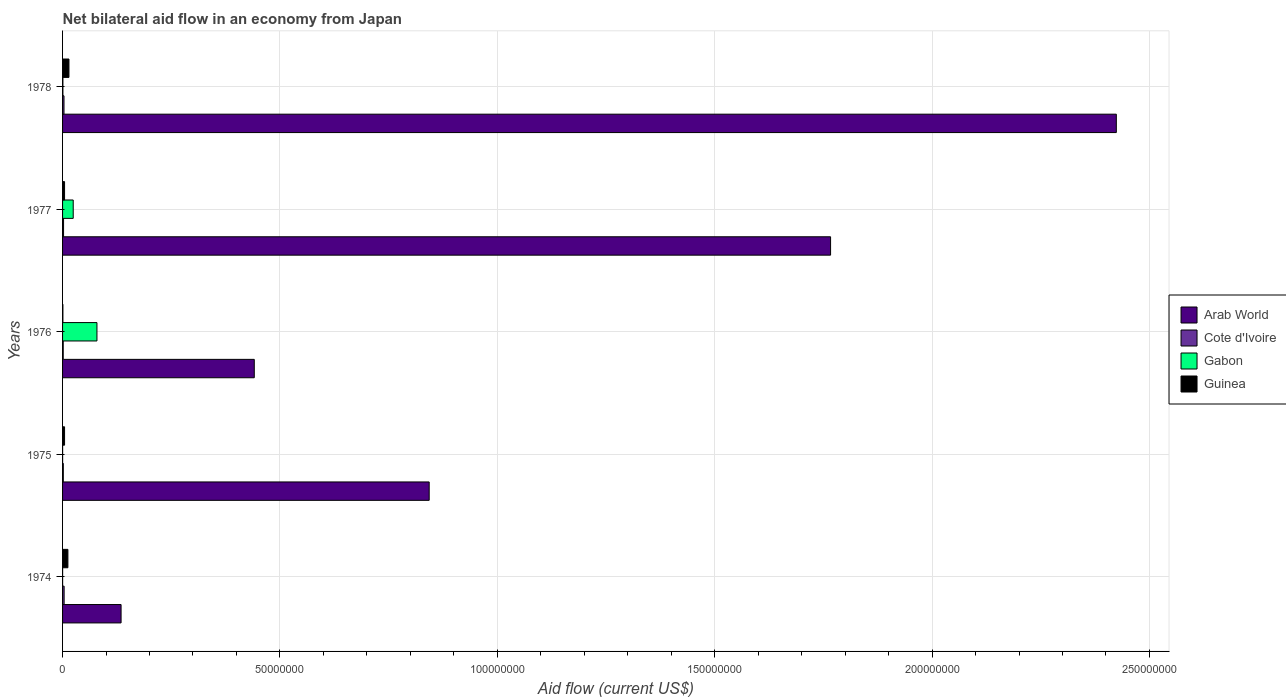Are the number of bars per tick equal to the number of legend labels?
Provide a succinct answer. Yes. Are the number of bars on each tick of the Y-axis equal?
Make the answer very short. Yes. How many bars are there on the 3rd tick from the bottom?
Make the answer very short. 4. What is the label of the 5th group of bars from the top?
Keep it short and to the point. 1974. Across all years, what is the maximum net bilateral aid flow in Gabon?
Your answer should be very brief. 7.91e+06. In which year was the net bilateral aid flow in Guinea maximum?
Keep it short and to the point. 1978. In which year was the net bilateral aid flow in Cote d'Ivoire minimum?
Keep it short and to the point. 1976. What is the total net bilateral aid flow in Arab World in the graph?
Your answer should be very brief. 5.61e+08. What is the difference between the net bilateral aid flow in Guinea in 1978 and the net bilateral aid flow in Cote d'Ivoire in 1977?
Make the answer very short. 1.24e+06. What is the average net bilateral aid flow in Arab World per year?
Your response must be concise. 1.12e+08. In the year 1978, what is the difference between the net bilateral aid flow in Arab World and net bilateral aid flow in Cote d'Ivoire?
Offer a very short reply. 2.42e+08. What is the ratio of the net bilateral aid flow in Cote d'Ivoire in 1974 to that in 1978?
Ensure brevity in your answer.  1.09. What is the difference between the highest and the second highest net bilateral aid flow in Arab World?
Your answer should be very brief. 6.57e+07. What is the difference between the highest and the lowest net bilateral aid flow in Gabon?
Your answer should be very brief. 7.90e+06. Is the sum of the net bilateral aid flow in Gabon in 1975 and 1977 greater than the maximum net bilateral aid flow in Cote d'Ivoire across all years?
Offer a terse response. Yes. What does the 2nd bar from the top in 1977 represents?
Your answer should be compact. Gabon. What does the 4th bar from the bottom in 1974 represents?
Keep it short and to the point. Guinea. Is it the case that in every year, the sum of the net bilateral aid flow in Arab World and net bilateral aid flow in Cote d'Ivoire is greater than the net bilateral aid flow in Gabon?
Provide a short and direct response. Yes. How many bars are there?
Ensure brevity in your answer.  20. Are the values on the major ticks of X-axis written in scientific E-notation?
Give a very brief answer. No. How are the legend labels stacked?
Your answer should be compact. Vertical. What is the title of the graph?
Offer a terse response. Net bilateral aid flow in an economy from Japan. What is the label or title of the X-axis?
Offer a terse response. Aid flow (current US$). What is the label or title of the Y-axis?
Keep it short and to the point. Years. What is the Aid flow (current US$) of Arab World in 1974?
Offer a very short reply. 1.35e+07. What is the Aid flow (current US$) in Guinea in 1974?
Provide a succinct answer. 1.23e+06. What is the Aid flow (current US$) of Arab World in 1975?
Your answer should be compact. 8.43e+07. What is the Aid flow (current US$) of Cote d'Ivoire in 1975?
Provide a short and direct response. 1.70e+05. What is the Aid flow (current US$) of Gabon in 1975?
Your answer should be very brief. 10000. What is the Aid flow (current US$) of Guinea in 1975?
Make the answer very short. 4.60e+05. What is the Aid flow (current US$) of Arab World in 1976?
Offer a very short reply. 4.41e+07. What is the Aid flow (current US$) of Gabon in 1976?
Your answer should be very brief. 7.91e+06. What is the Aid flow (current US$) of Guinea in 1976?
Ensure brevity in your answer.  8.00e+04. What is the Aid flow (current US$) of Arab World in 1977?
Ensure brevity in your answer.  1.77e+08. What is the Aid flow (current US$) in Gabon in 1977?
Keep it short and to the point. 2.45e+06. What is the Aid flow (current US$) in Arab World in 1978?
Your response must be concise. 2.42e+08. What is the Aid flow (current US$) in Cote d'Ivoire in 1978?
Offer a terse response. 3.30e+05. What is the Aid flow (current US$) of Gabon in 1978?
Give a very brief answer. 8.00e+04. What is the Aid flow (current US$) in Guinea in 1978?
Ensure brevity in your answer.  1.47e+06. Across all years, what is the maximum Aid flow (current US$) of Arab World?
Offer a terse response. 2.42e+08. Across all years, what is the maximum Aid flow (current US$) of Gabon?
Provide a succinct answer. 7.91e+06. Across all years, what is the maximum Aid flow (current US$) in Guinea?
Ensure brevity in your answer.  1.47e+06. Across all years, what is the minimum Aid flow (current US$) in Arab World?
Give a very brief answer. 1.35e+07. What is the total Aid flow (current US$) of Arab World in the graph?
Offer a very short reply. 5.61e+08. What is the total Aid flow (current US$) of Cote d'Ivoire in the graph?
Your answer should be compact. 1.24e+06. What is the total Aid flow (current US$) in Gabon in the graph?
Provide a succinct answer. 1.05e+07. What is the total Aid flow (current US$) in Guinea in the graph?
Provide a succinct answer. 3.70e+06. What is the difference between the Aid flow (current US$) in Arab World in 1974 and that in 1975?
Ensure brevity in your answer.  -7.09e+07. What is the difference between the Aid flow (current US$) of Cote d'Ivoire in 1974 and that in 1975?
Provide a succinct answer. 1.90e+05. What is the difference between the Aid flow (current US$) of Guinea in 1974 and that in 1975?
Your answer should be compact. 7.70e+05. What is the difference between the Aid flow (current US$) of Arab World in 1974 and that in 1976?
Your answer should be compact. -3.06e+07. What is the difference between the Aid flow (current US$) in Gabon in 1974 and that in 1976?
Provide a succinct answer. -7.90e+06. What is the difference between the Aid flow (current US$) of Guinea in 1974 and that in 1976?
Offer a very short reply. 1.15e+06. What is the difference between the Aid flow (current US$) in Arab World in 1974 and that in 1977?
Offer a terse response. -1.63e+08. What is the difference between the Aid flow (current US$) in Gabon in 1974 and that in 1977?
Give a very brief answer. -2.44e+06. What is the difference between the Aid flow (current US$) in Guinea in 1974 and that in 1977?
Offer a very short reply. 7.70e+05. What is the difference between the Aid flow (current US$) of Arab World in 1974 and that in 1978?
Offer a terse response. -2.29e+08. What is the difference between the Aid flow (current US$) in Gabon in 1974 and that in 1978?
Offer a very short reply. -7.00e+04. What is the difference between the Aid flow (current US$) in Arab World in 1975 and that in 1976?
Give a very brief answer. 4.02e+07. What is the difference between the Aid flow (current US$) of Cote d'Ivoire in 1975 and that in 1976?
Make the answer very short. 2.00e+04. What is the difference between the Aid flow (current US$) of Gabon in 1975 and that in 1976?
Ensure brevity in your answer.  -7.90e+06. What is the difference between the Aid flow (current US$) of Guinea in 1975 and that in 1976?
Your answer should be very brief. 3.80e+05. What is the difference between the Aid flow (current US$) of Arab World in 1975 and that in 1977?
Keep it short and to the point. -9.23e+07. What is the difference between the Aid flow (current US$) of Gabon in 1975 and that in 1977?
Make the answer very short. -2.44e+06. What is the difference between the Aid flow (current US$) in Arab World in 1975 and that in 1978?
Provide a succinct answer. -1.58e+08. What is the difference between the Aid flow (current US$) of Cote d'Ivoire in 1975 and that in 1978?
Offer a very short reply. -1.60e+05. What is the difference between the Aid flow (current US$) of Gabon in 1975 and that in 1978?
Your response must be concise. -7.00e+04. What is the difference between the Aid flow (current US$) of Guinea in 1975 and that in 1978?
Make the answer very short. -1.01e+06. What is the difference between the Aid flow (current US$) of Arab World in 1976 and that in 1977?
Give a very brief answer. -1.33e+08. What is the difference between the Aid flow (current US$) of Gabon in 1976 and that in 1977?
Your response must be concise. 5.46e+06. What is the difference between the Aid flow (current US$) of Guinea in 1976 and that in 1977?
Your answer should be very brief. -3.80e+05. What is the difference between the Aid flow (current US$) of Arab World in 1976 and that in 1978?
Ensure brevity in your answer.  -1.98e+08. What is the difference between the Aid flow (current US$) of Cote d'Ivoire in 1976 and that in 1978?
Offer a very short reply. -1.80e+05. What is the difference between the Aid flow (current US$) of Gabon in 1976 and that in 1978?
Ensure brevity in your answer.  7.83e+06. What is the difference between the Aid flow (current US$) of Guinea in 1976 and that in 1978?
Provide a short and direct response. -1.39e+06. What is the difference between the Aid flow (current US$) in Arab World in 1977 and that in 1978?
Your answer should be very brief. -6.57e+07. What is the difference between the Aid flow (current US$) in Cote d'Ivoire in 1977 and that in 1978?
Offer a very short reply. -1.00e+05. What is the difference between the Aid flow (current US$) in Gabon in 1977 and that in 1978?
Your answer should be compact. 2.37e+06. What is the difference between the Aid flow (current US$) in Guinea in 1977 and that in 1978?
Ensure brevity in your answer.  -1.01e+06. What is the difference between the Aid flow (current US$) of Arab World in 1974 and the Aid flow (current US$) of Cote d'Ivoire in 1975?
Provide a succinct answer. 1.33e+07. What is the difference between the Aid flow (current US$) of Arab World in 1974 and the Aid flow (current US$) of Gabon in 1975?
Give a very brief answer. 1.34e+07. What is the difference between the Aid flow (current US$) of Arab World in 1974 and the Aid flow (current US$) of Guinea in 1975?
Make the answer very short. 1.30e+07. What is the difference between the Aid flow (current US$) in Cote d'Ivoire in 1974 and the Aid flow (current US$) in Gabon in 1975?
Provide a succinct answer. 3.50e+05. What is the difference between the Aid flow (current US$) in Cote d'Ivoire in 1974 and the Aid flow (current US$) in Guinea in 1975?
Offer a very short reply. -1.00e+05. What is the difference between the Aid flow (current US$) in Gabon in 1974 and the Aid flow (current US$) in Guinea in 1975?
Your answer should be very brief. -4.50e+05. What is the difference between the Aid flow (current US$) in Arab World in 1974 and the Aid flow (current US$) in Cote d'Ivoire in 1976?
Make the answer very short. 1.33e+07. What is the difference between the Aid flow (current US$) in Arab World in 1974 and the Aid flow (current US$) in Gabon in 1976?
Your answer should be very brief. 5.55e+06. What is the difference between the Aid flow (current US$) in Arab World in 1974 and the Aid flow (current US$) in Guinea in 1976?
Your answer should be compact. 1.34e+07. What is the difference between the Aid flow (current US$) of Cote d'Ivoire in 1974 and the Aid flow (current US$) of Gabon in 1976?
Provide a short and direct response. -7.55e+06. What is the difference between the Aid flow (current US$) of Gabon in 1974 and the Aid flow (current US$) of Guinea in 1976?
Provide a short and direct response. -7.00e+04. What is the difference between the Aid flow (current US$) of Arab World in 1974 and the Aid flow (current US$) of Cote d'Ivoire in 1977?
Your answer should be compact. 1.32e+07. What is the difference between the Aid flow (current US$) in Arab World in 1974 and the Aid flow (current US$) in Gabon in 1977?
Your response must be concise. 1.10e+07. What is the difference between the Aid flow (current US$) in Arab World in 1974 and the Aid flow (current US$) in Guinea in 1977?
Your answer should be compact. 1.30e+07. What is the difference between the Aid flow (current US$) in Cote d'Ivoire in 1974 and the Aid flow (current US$) in Gabon in 1977?
Offer a terse response. -2.09e+06. What is the difference between the Aid flow (current US$) in Gabon in 1974 and the Aid flow (current US$) in Guinea in 1977?
Make the answer very short. -4.50e+05. What is the difference between the Aid flow (current US$) of Arab World in 1974 and the Aid flow (current US$) of Cote d'Ivoire in 1978?
Keep it short and to the point. 1.31e+07. What is the difference between the Aid flow (current US$) of Arab World in 1974 and the Aid flow (current US$) of Gabon in 1978?
Offer a very short reply. 1.34e+07. What is the difference between the Aid flow (current US$) of Arab World in 1974 and the Aid flow (current US$) of Guinea in 1978?
Keep it short and to the point. 1.20e+07. What is the difference between the Aid flow (current US$) in Cote d'Ivoire in 1974 and the Aid flow (current US$) in Gabon in 1978?
Offer a very short reply. 2.80e+05. What is the difference between the Aid flow (current US$) in Cote d'Ivoire in 1974 and the Aid flow (current US$) in Guinea in 1978?
Make the answer very short. -1.11e+06. What is the difference between the Aid flow (current US$) in Gabon in 1974 and the Aid flow (current US$) in Guinea in 1978?
Ensure brevity in your answer.  -1.46e+06. What is the difference between the Aid flow (current US$) of Arab World in 1975 and the Aid flow (current US$) of Cote d'Ivoire in 1976?
Your answer should be compact. 8.42e+07. What is the difference between the Aid flow (current US$) in Arab World in 1975 and the Aid flow (current US$) in Gabon in 1976?
Keep it short and to the point. 7.64e+07. What is the difference between the Aid flow (current US$) in Arab World in 1975 and the Aid flow (current US$) in Guinea in 1976?
Provide a short and direct response. 8.42e+07. What is the difference between the Aid flow (current US$) in Cote d'Ivoire in 1975 and the Aid flow (current US$) in Gabon in 1976?
Your answer should be compact. -7.74e+06. What is the difference between the Aid flow (current US$) in Gabon in 1975 and the Aid flow (current US$) in Guinea in 1976?
Keep it short and to the point. -7.00e+04. What is the difference between the Aid flow (current US$) of Arab World in 1975 and the Aid flow (current US$) of Cote d'Ivoire in 1977?
Offer a terse response. 8.41e+07. What is the difference between the Aid flow (current US$) in Arab World in 1975 and the Aid flow (current US$) in Gabon in 1977?
Offer a terse response. 8.19e+07. What is the difference between the Aid flow (current US$) of Arab World in 1975 and the Aid flow (current US$) of Guinea in 1977?
Keep it short and to the point. 8.39e+07. What is the difference between the Aid flow (current US$) in Cote d'Ivoire in 1975 and the Aid flow (current US$) in Gabon in 1977?
Ensure brevity in your answer.  -2.28e+06. What is the difference between the Aid flow (current US$) in Gabon in 1975 and the Aid flow (current US$) in Guinea in 1977?
Your answer should be compact. -4.50e+05. What is the difference between the Aid flow (current US$) in Arab World in 1975 and the Aid flow (current US$) in Cote d'Ivoire in 1978?
Your answer should be very brief. 8.40e+07. What is the difference between the Aid flow (current US$) of Arab World in 1975 and the Aid flow (current US$) of Gabon in 1978?
Give a very brief answer. 8.42e+07. What is the difference between the Aid flow (current US$) of Arab World in 1975 and the Aid flow (current US$) of Guinea in 1978?
Make the answer very short. 8.29e+07. What is the difference between the Aid flow (current US$) in Cote d'Ivoire in 1975 and the Aid flow (current US$) in Gabon in 1978?
Offer a very short reply. 9.00e+04. What is the difference between the Aid flow (current US$) in Cote d'Ivoire in 1975 and the Aid flow (current US$) in Guinea in 1978?
Your answer should be very brief. -1.30e+06. What is the difference between the Aid flow (current US$) of Gabon in 1975 and the Aid flow (current US$) of Guinea in 1978?
Ensure brevity in your answer.  -1.46e+06. What is the difference between the Aid flow (current US$) in Arab World in 1976 and the Aid flow (current US$) in Cote d'Ivoire in 1977?
Your response must be concise. 4.39e+07. What is the difference between the Aid flow (current US$) of Arab World in 1976 and the Aid flow (current US$) of Gabon in 1977?
Offer a terse response. 4.16e+07. What is the difference between the Aid flow (current US$) of Arab World in 1976 and the Aid flow (current US$) of Guinea in 1977?
Keep it short and to the point. 4.36e+07. What is the difference between the Aid flow (current US$) in Cote d'Ivoire in 1976 and the Aid flow (current US$) in Gabon in 1977?
Give a very brief answer. -2.30e+06. What is the difference between the Aid flow (current US$) in Cote d'Ivoire in 1976 and the Aid flow (current US$) in Guinea in 1977?
Make the answer very short. -3.10e+05. What is the difference between the Aid flow (current US$) of Gabon in 1976 and the Aid flow (current US$) of Guinea in 1977?
Provide a succinct answer. 7.45e+06. What is the difference between the Aid flow (current US$) of Arab World in 1976 and the Aid flow (current US$) of Cote d'Ivoire in 1978?
Your answer should be very brief. 4.38e+07. What is the difference between the Aid flow (current US$) in Arab World in 1976 and the Aid flow (current US$) in Gabon in 1978?
Offer a terse response. 4.40e+07. What is the difference between the Aid flow (current US$) in Arab World in 1976 and the Aid flow (current US$) in Guinea in 1978?
Give a very brief answer. 4.26e+07. What is the difference between the Aid flow (current US$) in Cote d'Ivoire in 1976 and the Aid flow (current US$) in Gabon in 1978?
Your response must be concise. 7.00e+04. What is the difference between the Aid flow (current US$) in Cote d'Ivoire in 1976 and the Aid flow (current US$) in Guinea in 1978?
Keep it short and to the point. -1.32e+06. What is the difference between the Aid flow (current US$) in Gabon in 1976 and the Aid flow (current US$) in Guinea in 1978?
Give a very brief answer. 6.44e+06. What is the difference between the Aid flow (current US$) of Arab World in 1977 and the Aid flow (current US$) of Cote d'Ivoire in 1978?
Ensure brevity in your answer.  1.76e+08. What is the difference between the Aid flow (current US$) in Arab World in 1977 and the Aid flow (current US$) in Gabon in 1978?
Ensure brevity in your answer.  1.77e+08. What is the difference between the Aid flow (current US$) of Arab World in 1977 and the Aid flow (current US$) of Guinea in 1978?
Make the answer very short. 1.75e+08. What is the difference between the Aid flow (current US$) of Cote d'Ivoire in 1977 and the Aid flow (current US$) of Guinea in 1978?
Provide a short and direct response. -1.24e+06. What is the difference between the Aid flow (current US$) of Gabon in 1977 and the Aid flow (current US$) of Guinea in 1978?
Your response must be concise. 9.80e+05. What is the average Aid flow (current US$) in Arab World per year?
Your answer should be very brief. 1.12e+08. What is the average Aid flow (current US$) in Cote d'Ivoire per year?
Provide a short and direct response. 2.48e+05. What is the average Aid flow (current US$) of Gabon per year?
Your answer should be very brief. 2.09e+06. What is the average Aid flow (current US$) of Guinea per year?
Provide a short and direct response. 7.40e+05. In the year 1974, what is the difference between the Aid flow (current US$) in Arab World and Aid flow (current US$) in Cote d'Ivoire?
Ensure brevity in your answer.  1.31e+07. In the year 1974, what is the difference between the Aid flow (current US$) in Arab World and Aid flow (current US$) in Gabon?
Your answer should be very brief. 1.34e+07. In the year 1974, what is the difference between the Aid flow (current US$) in Arab World and Aid flow (current US$) in Guinea?
Your answer should be compact. 1.22e+07. In the year 1974, what is the difference between the Aid flow (current US$) in Cote d'Ivoire and Aid flow (current US$) in Gabon?
Make the answer very short. 3.50e+05. In the year 1974, what is the difference between the Aid flow (current US$) in Cote d'Ivoire and Aid flow (current US$) in Guinea?
Your answer should be compact. -8.70e+05. In the year 1974, what is the difference between the Aid flow (current US$) in Gabon and Aid flow (current US$) in Guinea?
Provide a short and direct response. -1.22e+06. In the year 1975, what is the difference between the Aid flow (current US$) in Arab World and Aid flow (current US$) in Cote d'Ivoire?
Provide a short and direct response. 8.42e+07. In the year 1975, what is the difference between the Aid flow (current US$) of Arab World and Aid flow (current US$) of Gabon?
Your answer should be very brief. 8.43e+07. In the year 1975, what is the difference between the Aid flow (current US$) in Arab World and Aid flow (current US$) in Guinea?
Your answer should be very brief. 8.39e+07. In the year 1975, what is the difference between the Aid flow (current US$) in Cote d'Ivoire and Aid flow (current US$) in Gabon?
Your answer should be very brief. 1.60e+05. In the year 1975, what is the difference between the Aid flow (current US$) in Gabon and Aid flow (current US$) in Guinea?
Ensure brevity in your answer.  -4.50e+05. In the year 1976, what is the difference between the Aid flow (current US$) in Arab World and Aid flow (current US$) in Cote d'Ivoire?
Offer a very short reply. 4.40e+07. In the year 1976, what is the difference between the Aid flow (current US$) of Arab World and Aid flow (current US$) of Gabon?
Ensure brevity in your answer.  3.62e+07. In the year 1976, what is the difference between the Aid flow (current US$) of Arab World and Aid flow (current US$) of Guinea?
Offer a very short reply. 4.40e+07. In the year 1976, what is the difference between the Aid flow (current US$) in Cote d'Ivoire and Aid flow (current US$) in Gabon?
Make the answer very short. -7.76e+06. In the year 1976, what is the difference between the Aid flow (current US$) of Cote d'Ivoire and Aid flow (current US$) of Guinea?
Provide a succinct answer. 7.00e+04. In the year 1976, what is the difference between the Aid flow (current US$) of Gabon and Aid flow (current US$) of Guinea?
Offer a terse response. 7.83e+06. In the year 1977, what is the difference between the Aid flow (current US$) of Arab World and Aid flow (current US$) of Cote d'Ivoire?
Your response must be concise. 1.76e+08. In the year 1977, what is the difference between the Aid flow (current US$) in Arab World and Aid flow (current US$) in Gabon?
Provide a succinct answer. 1.74e+08. In the year 1977, what is the difference between the Aid flow (current US$) in Arab World and Aid flow (current US$) in Guinea?
Offer a very short reply. 1.76e+08. In the year 1977, what is the difference between the Aid flow (current US$) of Cote d'Ivoire and Aid flow (current US$) of Gabon?
Your response must be concise. -2.22e+06. In the year 1977, what is the difference between the Aid flow (current US$) of Cote d'Ivoire and Aid flow (current US$) of Guinea?
Ensure brevity in your answer.  -2.30e+05. In the year 1977, what is the difference between the Aid flow (current US$) in Gabon and Aid flow (current US$) in Guinea?
Provide a succinct answer. 1.99e+06. In the year 1978, what is the difference between the Aid flow (current US$) of Arab World and Aid flow (current US$) of Cote d'Ivoire?
Your answer should be very brief. 2.42e+08. In the year 1978, what is the difference between the Aid flow (current US$) in Arab World and Aid flow (current US$) in Gabon?
Keep it short and to the point. 2.42e+08. In the year 1978, what is the difference between the Aid flow (current US$) of Arab World and Aid flow (current US$) of Guinea?
Offer a very short reply. 2.41e+08. In the year 1978, what is the difference between the Aid flow (current US$) of Cote d'Ivoire and Aid flow (current US$) of Guinea?
Your response must be concise. -1.14e+06. In the year 1978, what is the difference between the Aid flow (current US$) in Gabon and Aid flow (current US$) in Guinea?
Keep it short and to the point. -1.39e+06. What is the ratio of the Aid flow (current US$) of Arab World in 1974 to that in 1975?
Ensure brevity in your answer.  0.16. What is the ratio of the Aid flow (current US$) of Cote d'Ivoire in 1974 to that in 1975?
Provide a succinct answer. 2.12. What is the ratio of the Aid flow (current US$) in Guinea in 1974 to that in 1975?
Your response must be concise. 2.67. What is the ratio of the Aid flow (current US$) in Arab World in 1974 to that in 1976?
Keep it short and to the point. 0.31. What is the ratio of the Aid flow (current US$) in Gabon in 1974 to that in 1976?
Keep it short and to the point. 0. What is the ratio of the Aid flow (current US$) in Guinea in 1974 to that in 1976?
Provide a succinct answer. 15.38. What is the ratio of the Aid flow (current US$) of Arab World in 1974 to that in 1977?
Your answer should be very brief. 0.08. What is the ratio of the Aid flow (current US$) in Cote d'Ivoire in 1974 to that in 1977?
Keep it short and to the point. 1.57. What is the ratio of the Aid flow (current US$) in Gabon in 1974 to that in 1977?
Your answer should be very brief. 0. What is the ratio of the Aid flow (current US$) of Guinea in 1974 to that in 1977?
Offer a terse response. 2.67. What is the ratio of the Aid flow (current US$) of Arab World in 1974 to that in 1978?
Your answer should be compact. 0.06. What is the ratio of the Aid flow (current US$) of Cote d'Ivoire in 1974 to that in 1978?
Provide a succinct answer. 1.09. What is the ratio of the Aid flow (current US$) of Gabon in 1974 to that in 1978?
Your answer should be compact. 0.12. What is the ratio of the Aid flow (current US$) in Guinea in 1974 to that in 1978?
Ensure brevity in your answer.  0.84. What is the ratio of the Aid flow (current US$) of Arab World in 1975 to that in 1976?
Keep it short and to the point. 1.91. What is the ratio of the Aid flow (current US$) of Cote d'Ivoire in 1975 to that in 1976?
Offer a very short reply. 1.13. What is the ratio of the Aid flow (current US$) of Gabon in 1975 to that in 1976?
Give a very brief answer. 0. What is the ratio of the Aid flow (current US$) in Guinea in 1975 to that in 1976?
Make the answer very short. 5.75. What is the ratio of the Aid flow (current US$) in Arab World in 1975 to that in 1977?
Provide a short and direct response. 0.48. What is the ratio of the Aid flow (current US$) of Cote d'Ivoire in 1975 to that in 1977?
Give a very brief answer. 0.74. What is the ratio of the Aid flow (current US$) of Gabon in 1975 to that in 1977?
Ensure brevity in your answer.  0. What is the ratio of the Aid flow (current US$) of Guinea in 1975 to that in 1977?
Your answer should be compact. 1. What is the ratio of the Aid flow (current US$) of Arab World in 1975 to that in 1978?
Your answer should be compact. 0.35. What is the ratio of the Aid flow (current US$) of Cote d'Ivoire in 1975 to that in 1978?
Offer a very short reply. 0.52. What is the ratio of the Aid flow (current US$) in Gabon in 1975 to that in 1978?
Provide a short and direct response. 0.12. What is the ratio of the Aid flow (current US$) of Guinea in 1975 to that in 1978?
Ensure brevity in your answer.  0.31. What is the ratio of the Aid flow (current US$) of Arab World in 1976 to that in 1977?
Give a very brief answer. 0.25. What is the ratio of the Aid flow (current US$) of Cote d'Ivoire in 1976 to that in 1977?
Provide a short and direct response. 0.65. What is the ratio of the Aid flow (current US$) in Gabon in 1976 to that in 1977?
Keep it short and to the point. 3.23. What is the ratio of the Aid flow (current US$) in Guinea in 1976 to that in 1977?
Keep it short and to the point. 0.17. What is the ratio of the Aid flow (current US$) in Arab World in 1976 to that in 1978?
Make the answer very short. 0.18. What is the ratio of the Aid flow (current US$) in Cote d'Ivoire in 1976 to that in 1978?
Keep it short and to the point. 0.45. What is the ratio of the Aid flow (current US$) in Gabon in 1976 to that in 1978?
Your response must be concise. 98.88. What is the ratio of the Aid flow (current US$) of Guinea in 1976 to that in 1978?
Give a very brief answer. 0.05. What is the ratio of the Aid flow (current US$) of Arab World in 1977 to that in 1978?
Offer a terse response. 0.73. What is the ratio of the Aid flow (current US$) of Cote d'Ivoire in 1977 to that in 1978?
Provide a short and direct response. 0.7. What is the ratio of the Aid flow (current US$) in Gabon in 1977 to that in 1978?
Keep it short and to the point. 30.62. What is the ratio of the Aid flow (current US$) in Guinea in 1977 to that in 1978?
Give a very brief answer. 0.31. What is the difference between the highest and the second highest Aid flow (current US$) of Arab World?
Your response must be concise. 6.57e+07. What is the difference between the highest and the second highest Aid flow (current US$) in Cote d'Ivoire?
Offer a terse response. 3.00e+04. What is the difference between the highest and the second highest Aid flow (current US$) in Gabon?
Provide a succinct answer. 5.46e+06. What is the difference between the highest and the lowest Aid flow (current US$) of Arab World?
Make the answer very short. 2.29e+08. What is the difference between the highest and the lowest Aid flow (current US$) in Cote d'Ivoire?
Provide a succinct answer. 2.10e+05. What is the difference between the highest and the lowest Aid flow (current US$) in Gabon?
Your answer should be compact. 7.90e+06. What is the difference between the highest and the lowest Aid flow (current US$) of Guinea?
Give a very brief answer. 1.39e+06. 